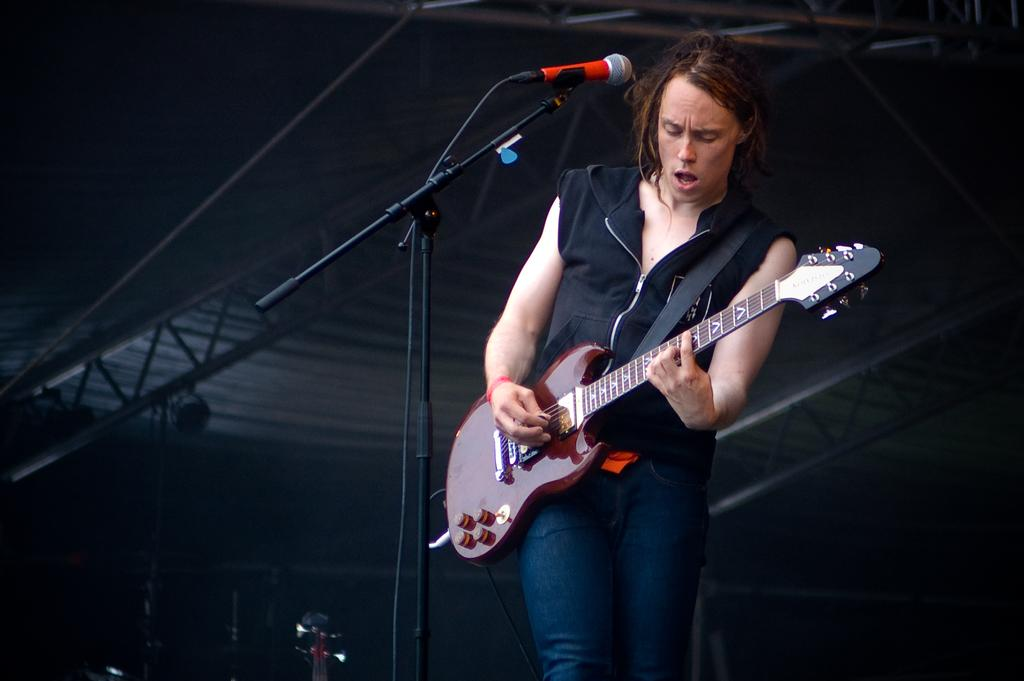What is the person in the image doing? There is a person playing a guitar in the image. What object is present for amplifying the person's voice? There is a microphone on a stand in the image. How would you describe the lighting in the image? The background of the image is dark. How many clocks can be seen hanging on the wall in the image? There are no clocks visible in the image. What type of cabbage is being used as a prop in the image? There is no cabbage present in the image. 